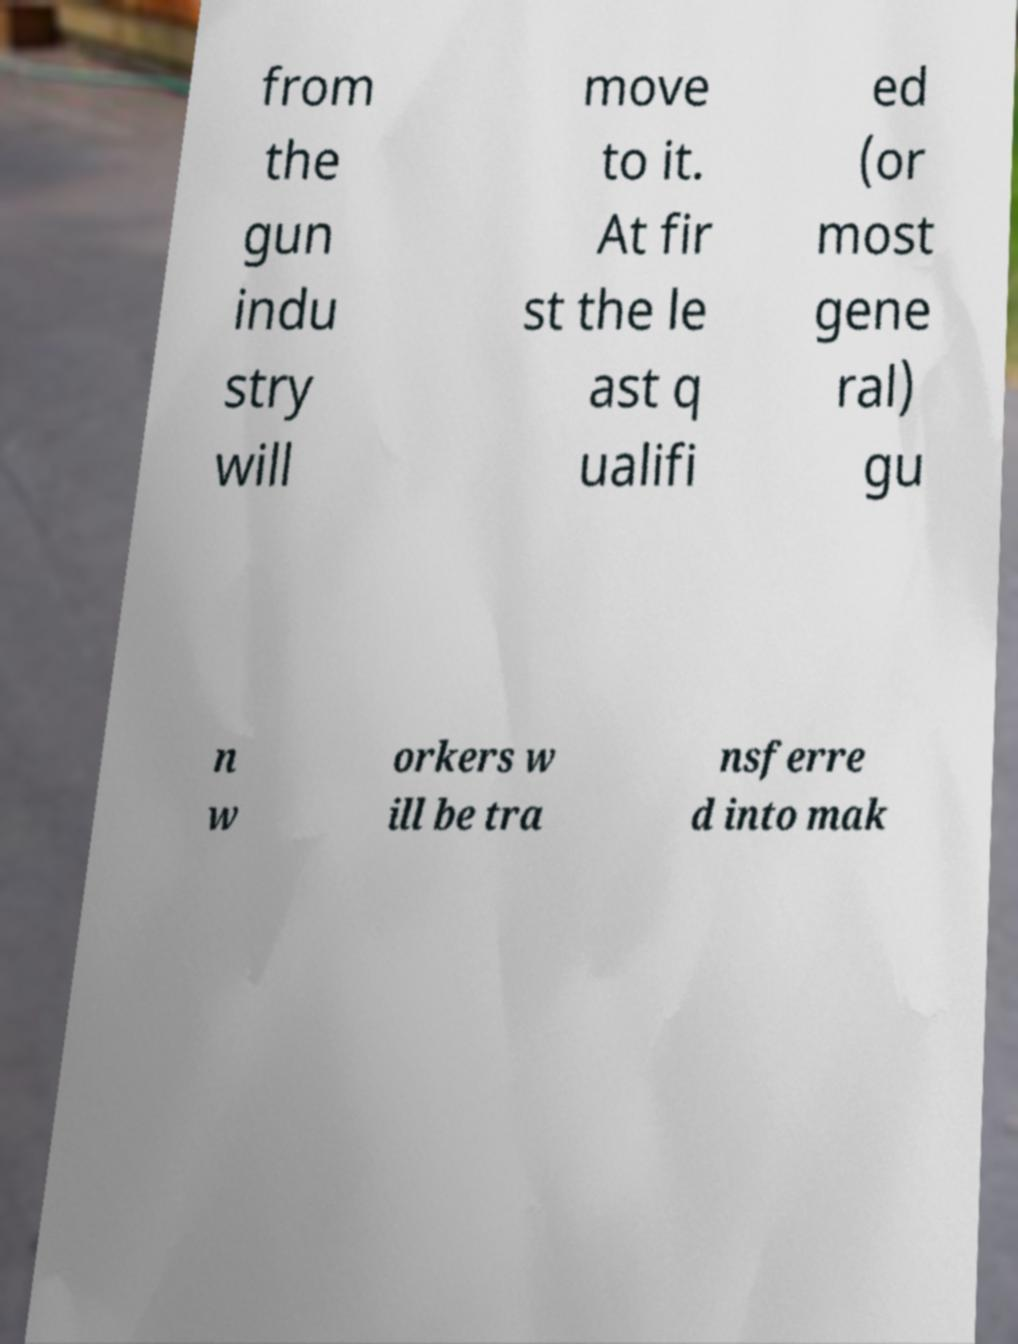What messages or text are displayed in this image? I need them in a readable, typed format. from the gun indu stry will move to it. At fir st the le ast q ualifi ed (or most gene ral) gu n w orkers w ill be tra nsferre d into mak 